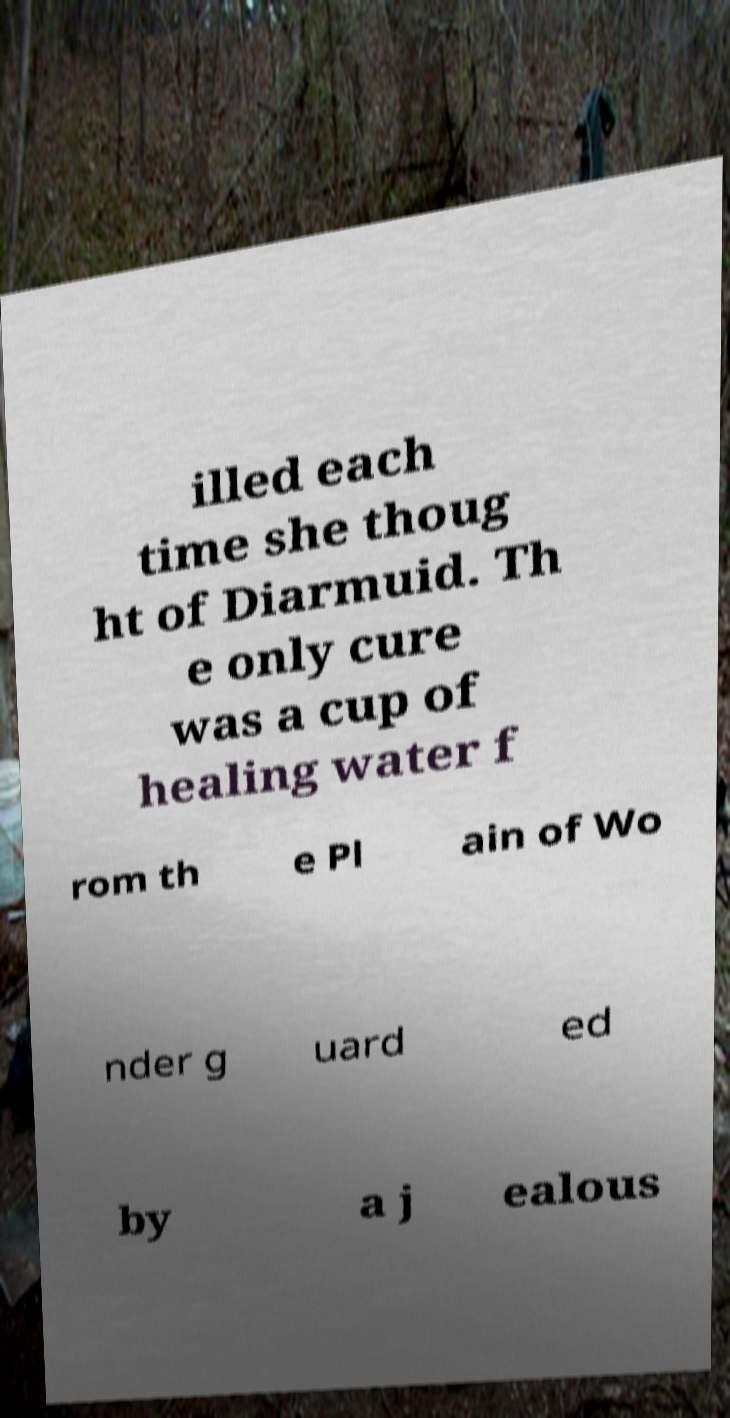Can you accurately transcribe the text from the provided image for me? illed each time she thoug ht of Diarmuid. Th e only cure was a cup of healing water f rom th e Pl ain of Wo nder g uard ed by a j ealous 